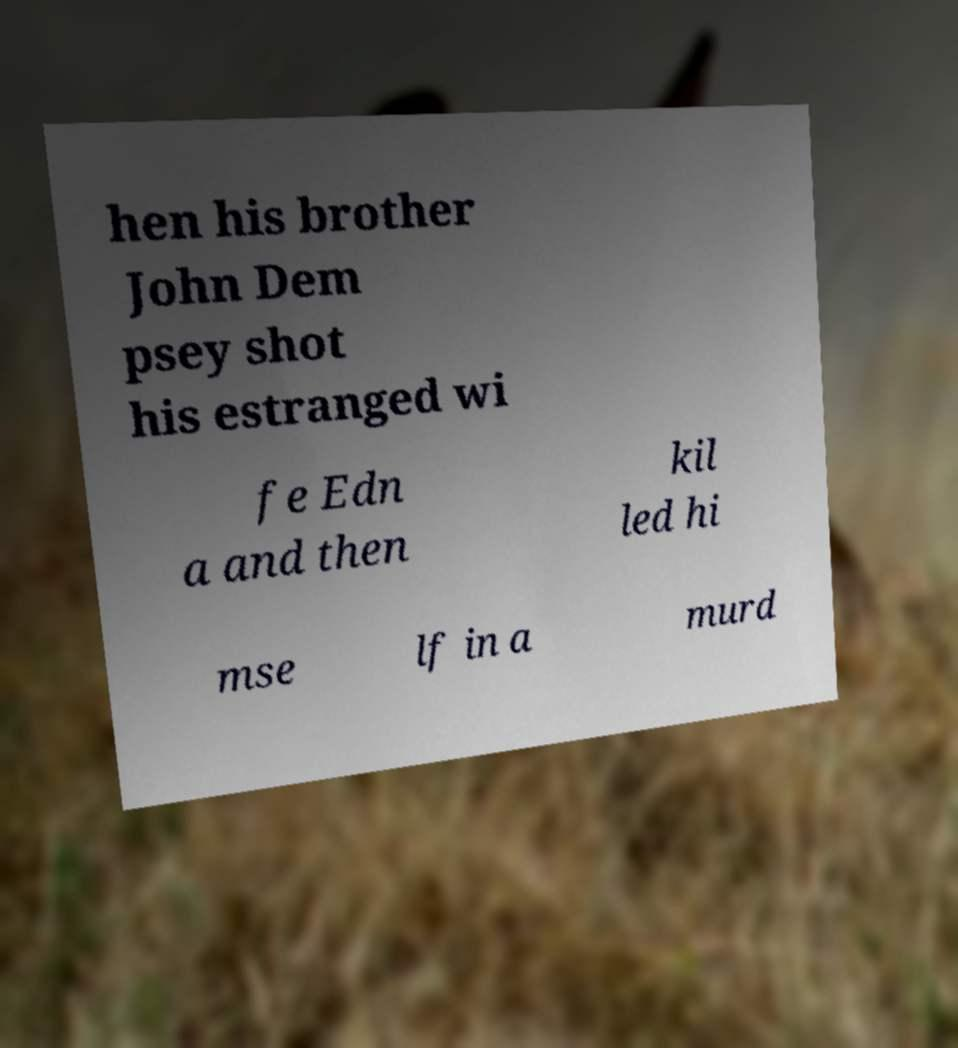I need the written content from this picture converted into text. Can you do that? hen his brother John Dem psey shot his estranged wi fe Edn a and then kil led hi mse lf in a murd 